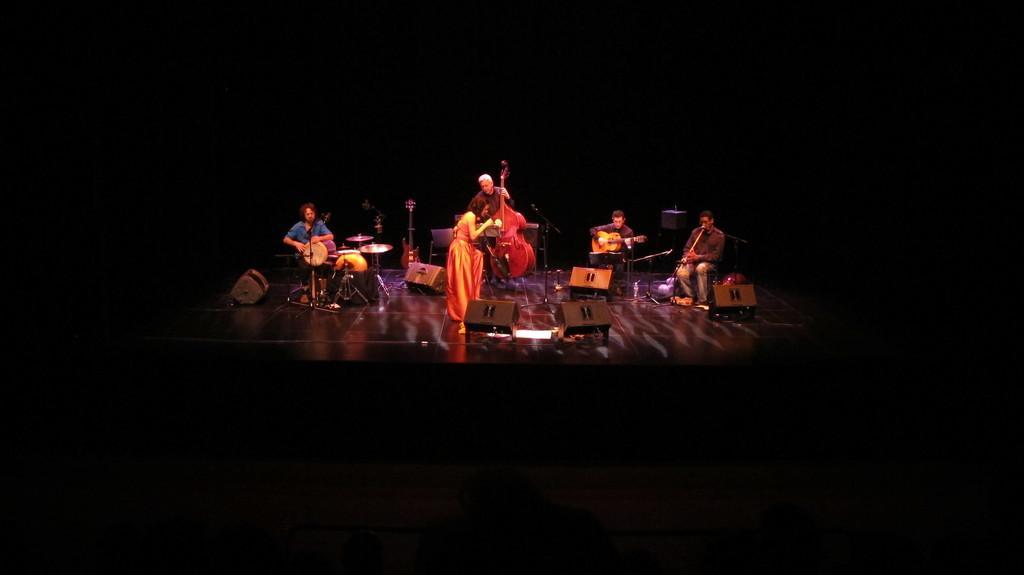Describe this image in one or two sentences. In this image we can see few people are playing musical instruments on the stage. A lady is standing on the stage in the image. There are many objects placed on the stage. There is a dark background in the image. 